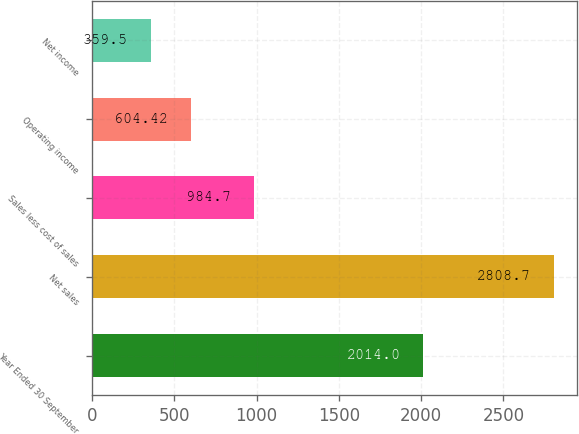Convert chart to OTSL. <chart><loc_0><loc_0><loc_500><loc_500><bar_chart><fcel>Year Ended 30 September<fcel>Net sales<fcel>Sales less cost of sales<fcel>Operating income<fcel>Net income<nl><fcel>2014<fcel>2808.7<fcel>984.7<fcel>604.42<fcel>359.5<nl></chart> 